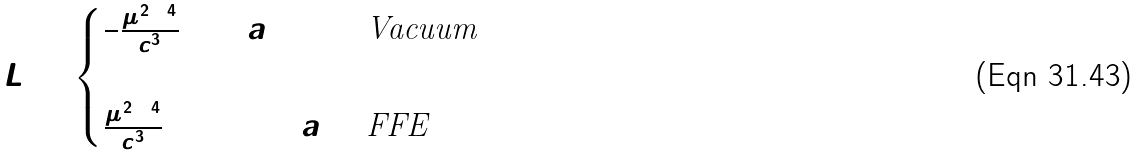<formula> <loc_0><loc_0><loc_500><loc_500>L = \begin{cases} \frac { 2 } { 3 } \frac { \mu ^ { 2 } \Omega ^ { 4 } } { c ^ { 3 } } \sin ^ { 2 } a & \text {Vacuum} \\ \\ \frac { \mu ^ { 2 } \Omega ^ { 4 } } { c ^ { 3 } } ( 1 + \sin ^ { 2 } a ) & \text {FFE} \end{cases}</formula> 